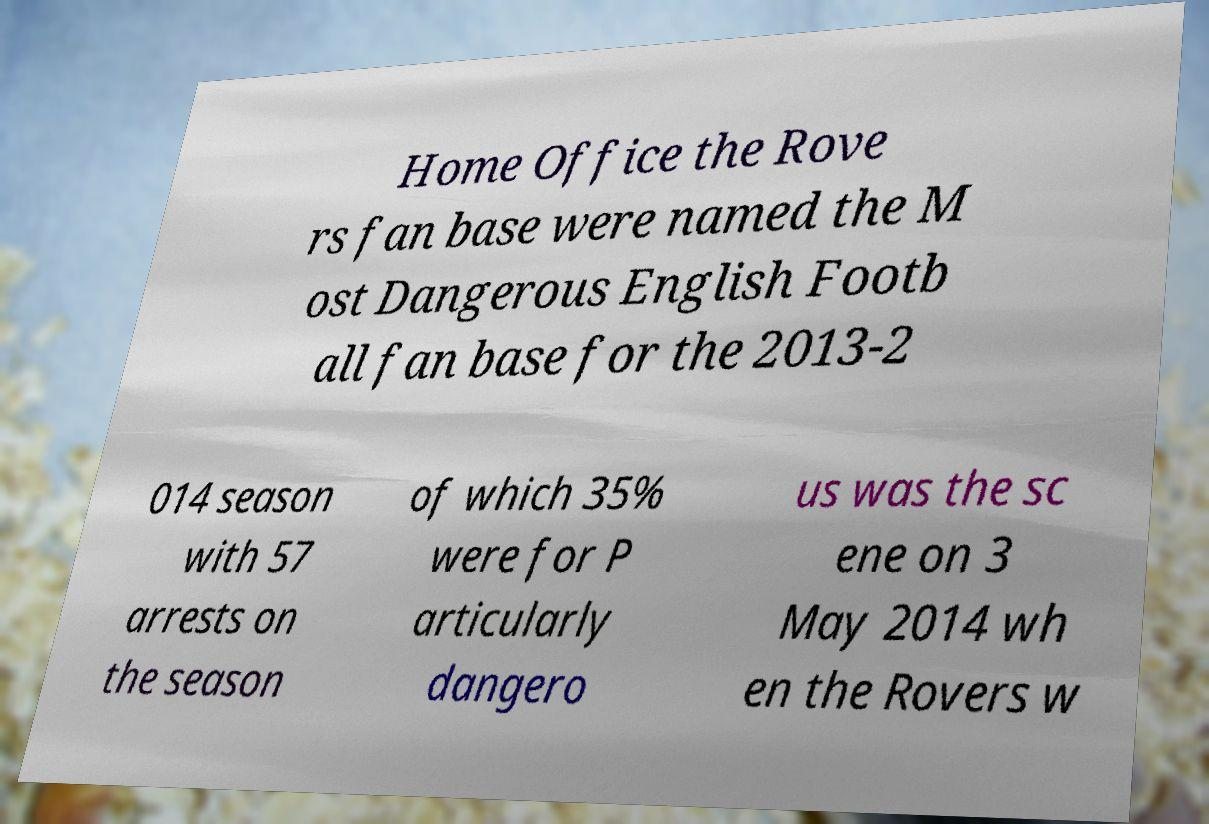Could you assist in decoding the text presented in this image and type it out clearly? Home Office the Rove rs fan base were named the M ost Dangerous English Footb all fan base for the 2013-2 014 season with 57 arrests on the season of which 35% were for P articularly dangero us was the sc ene on 3 May 2014 wh en the Rovers w 